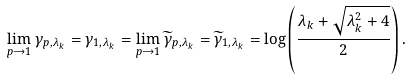Convert formula to latex. <formula><loc_0><loc_0><loc_500><loc_500>\lim _ { p \to 1 } \gamma _ { p , \lambda _ { k } } = \gamma _ { 1 , \lambda _ { k } } = \lim _ { p \to 1 } \widetilde { \gamma } _ { p , \lambda _ { k } } = \widetilde { \gamma } _ { 1 , \lambda _ { k } } = \log \left ( \frac { \lambda _ { k } + \sqrt { \lambda _ { k } ^ { 2 } + 4 } } { 2 } \right ) .</formula> 